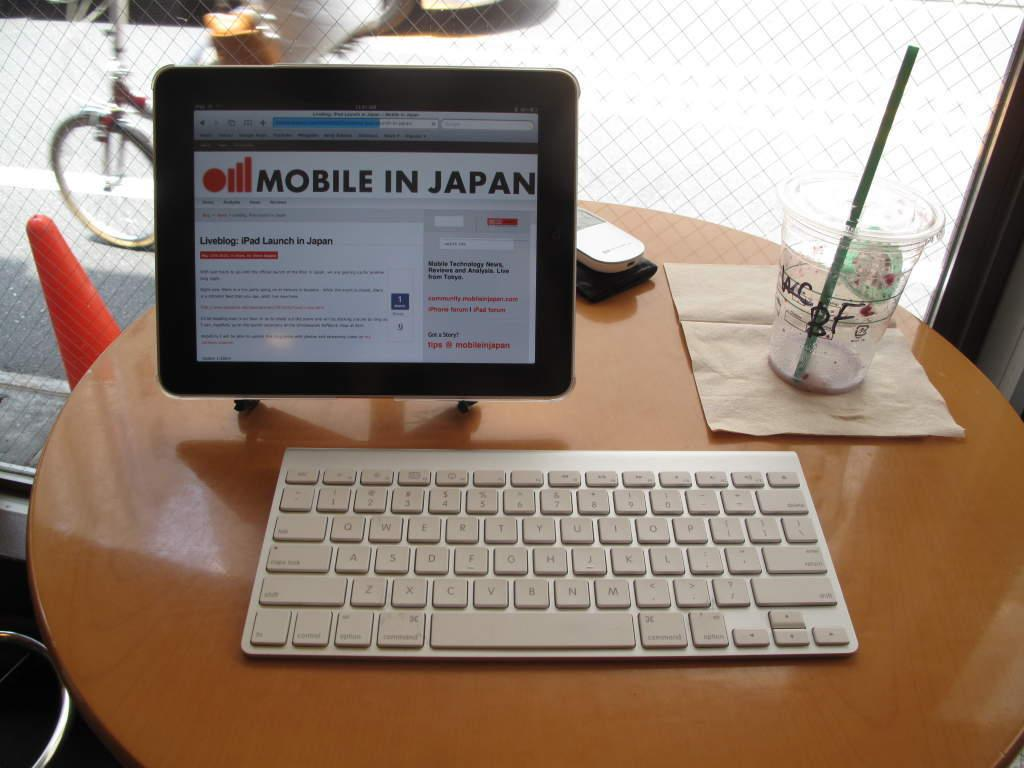What electronic device is visible in the image? There is a monitor in the image. What is used for input on the device? There is a keypad in the image for input. What is on the table next to the device? There is a glass with a straw in the image. What type of accessory is on the table? There is a kerchief on the table in the image. How many chairs are visible in the image? There are no chairs visible in the image. What is the cause of death in the image? There is no indication of death or any related events in the image. 